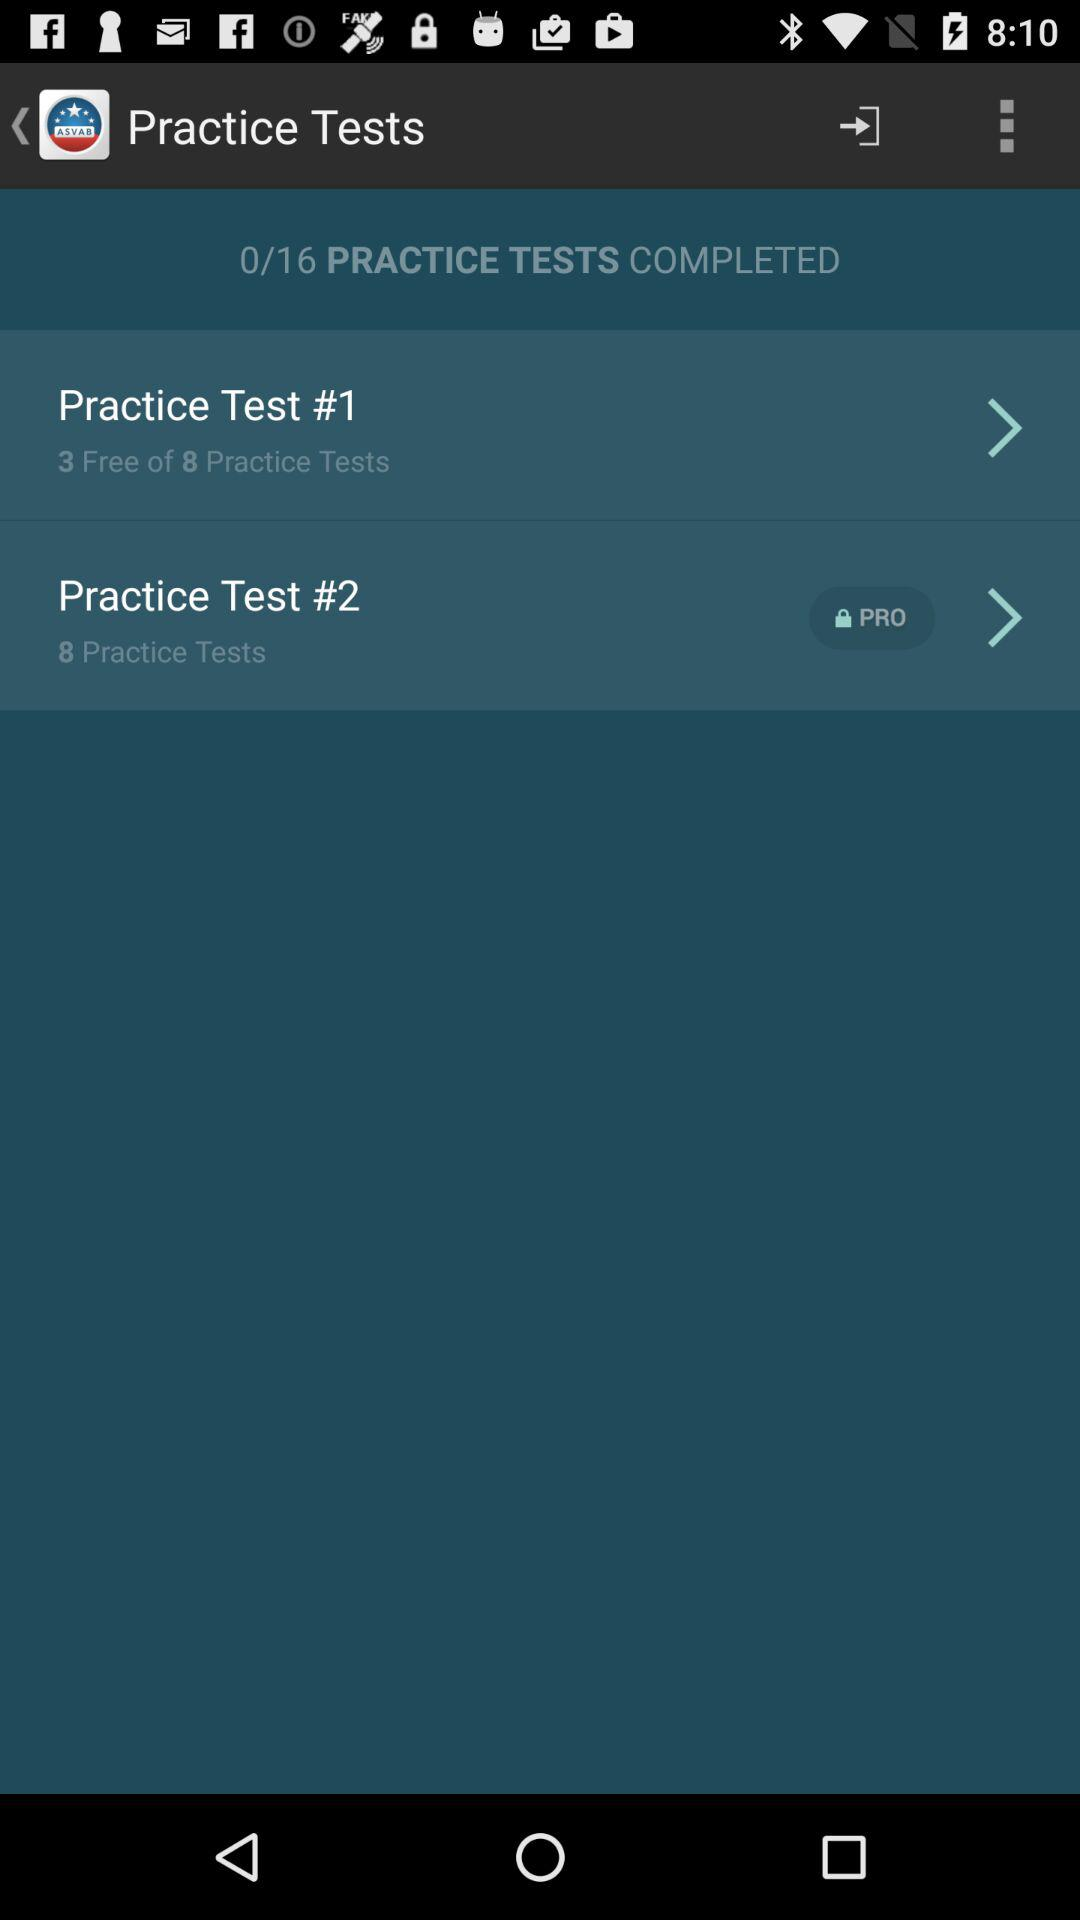What is the app name? The app name is "ASVAB". 